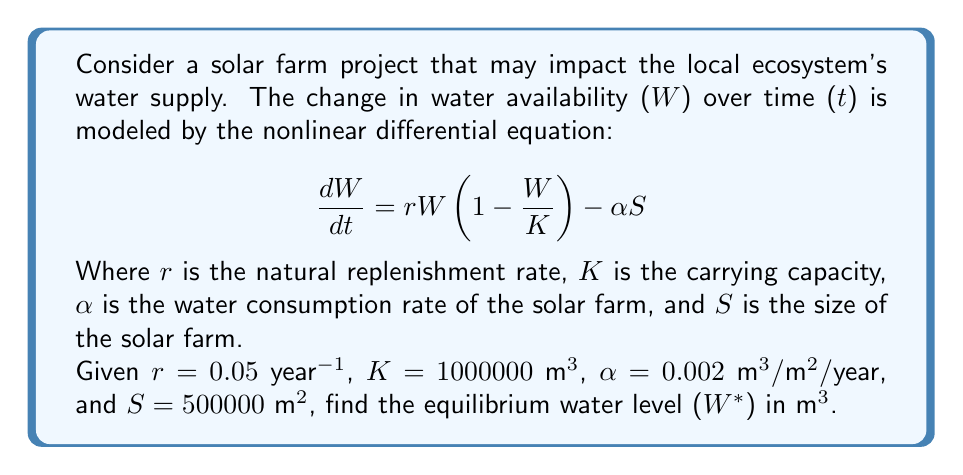Help me with this question. To find the equilibrium water level, we need to set the rate of change to zero:

$$\frac{dW}{dt} = 0$$

Substituting this into our equation:

$$0 = rW(1 - \frac{W}{K}) - \alpha S$$

Now, let's substitute the given values:

$$0 = 0.05W(1 - \frac{W}{1000000}) - 0.002 \cdot 500000$$

Simplify:

$$0 = 0.05W - \frac{0.05W^2}{1000000} - 1000$$

Multiply all terms by 1000000:

$$0 = 50000W - 0.05W^2 - 1000000000$$

Rearrange to standard quadratic form:

$$0.05W^2 - 50000W + 1000000000 = 0$$

Use the quadratic formula: $W = \frac{-b \pm \sqrt{b^2 - 4ac}}{2a}$

Where $a = 0.05$, $b = -50000$, and $c = 1000000000$

$$W = \frac{50000 \pm \sqrt{(-50000)^2 - 4(0.05)(1000000000)}}{2(0.05)}$$

$$W = \frac{50000 \pm \sqrt{2500000000 - 200000000}}{0.1}$$

$$W = \frac{50000 \pm \sqrt{2300000000}}{0.1}$$

$$W = \frac{50000 \pm 47958.315}{0.1}$$

This gives us two solutions:

$$W_1 = \frac{50000 + 47958.315}{0.1} = 979583.15$$

$$W_2 = \frac{50000 - 47958.315}{0.1} = 20416.85$$

The larger value (W₁) represents the stable equilibrium, which is the one we're interested in for long-term environmental impact.
Answer: 979583.15 m³ 